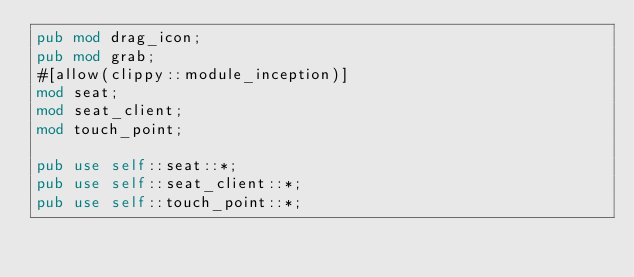<code> <loc_0><loc_0><loc_500><loc_500><_Rust_>pub mod drag_icon;
pub mod grab;
#[allow(clippy::module_inception)]
mod seat;
mod seat_client;
mod touch_point;

pub use self::seat::*;
pub use self::seat_client::*;
pub use self::touch_point::*;
</code> 